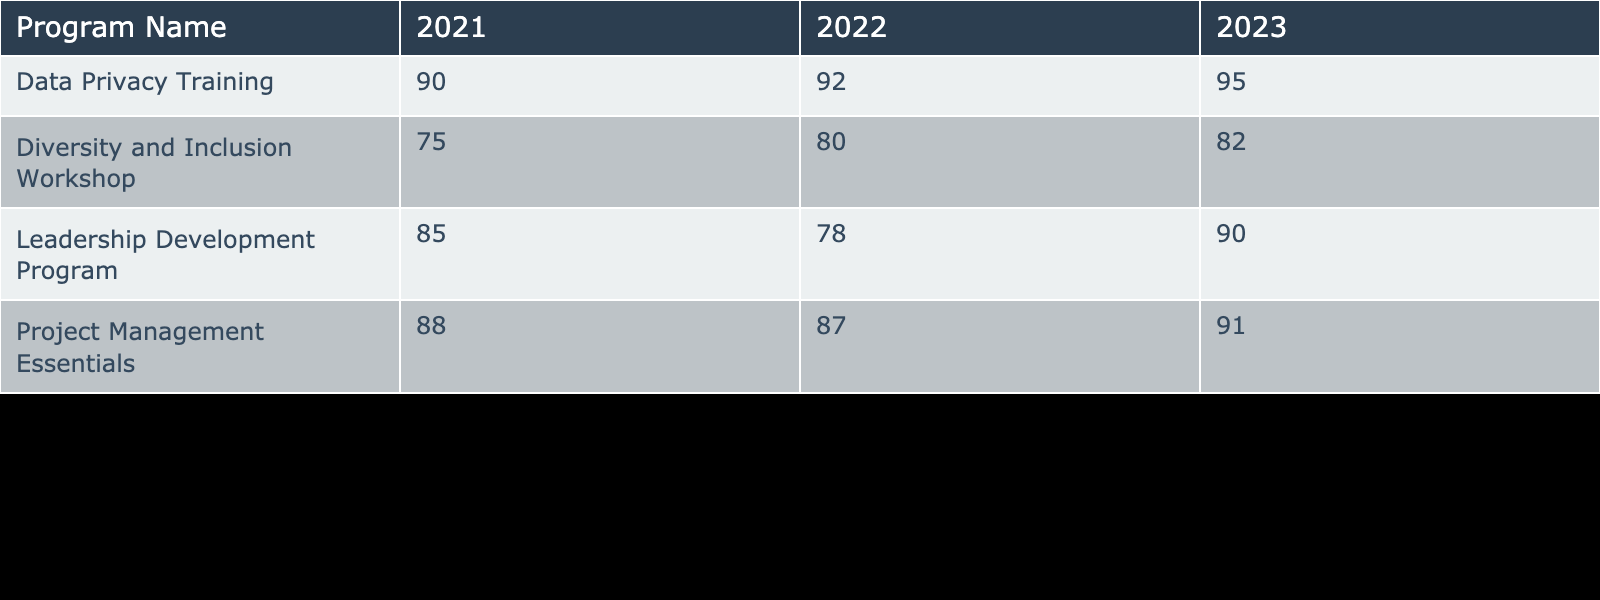What was the completion rate for the Data Privacy Training in 2022? According to the table, the completion rate for the Data Privacy Training in 2022 is listed directly under the corresponding year and program, which shows a completion rate of 92%.
Answer: 92% Which program had the highest completion rate in 2023? In the table, we look at the completion rates for each program in 2023. The Data Privacy Training has the highest completion rate at 95%.
Answer: 95% What is the average completion rate for the Leadership Development Program over the three years? We take the completion rates for the Leadership Development Program for all three years: 85% (2021), 78% (2022), and 90% (2023). The total is 85 + 78 + 90 = 253. Dividing by the number of years (3), we get an average of 253 / 3 = 84.33%.
Answer: 84.33% Did the Diversity and Inclusion Workshop see an increase in completion rates from 2021 to 2023? By examining the table, the completion rates for the Diversity and Inclusion Workshop are 75% in 2021, 80% in 2022, and 82% in 2023. This shows an increase each year from 75% to 80% to 82%.
Answer: Yes What is the difference in completion rates between the Project Management Essentials program in 2021 and 2023? We find the completion rates for the Project Management Essentials program: 88% in 2021 and 91% in 2023. To find the difference, we subtract the 2021 rate from the 2023 rate: 91% - 88% = 3%.
Answer: 3% 